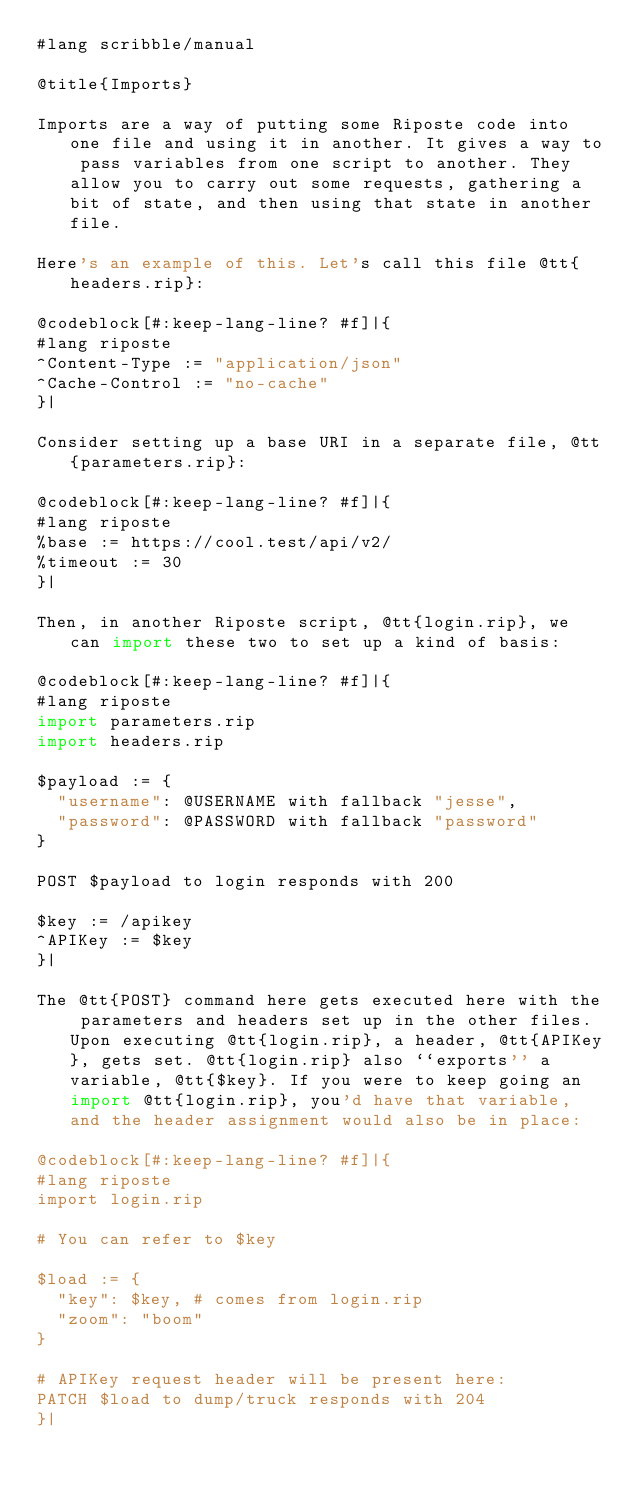Convert code to text. <code><loc_0><loc_0><loc_500><loc_500><_Racket_>#lang scribble/manual

@title{Imports}

Imports are a way of putting some Riposte code into one file and using it in another. It gives a way to pass variables from one script to another. They allow you to carry out some requests, gathering a bit of state, and then using that state in another file.

Here's an example of this. Let's call this file @tt{headers.rip}:

@codeblock[#:keep-lang-line? #f]|{
#lang riposte
^Content-Type := "application/json"
^Cache-Control := "no-cache"
}|

Consider setting up a base URI in a separate file, @tt{parameters.rip}:

@codeblock[#:keep-lang-line? #f]|{
#lang riposte
%base := https://cool.test/api/v2/
%timeout := 30
}|

Then, in another Riposte script, @tt{login.rip}, we can import these two to set up a kind of basis:

@codeblock[#:keep-lang-line? #f]|{
#lang riposte
import parameters.rip
import headers.rip

$payload := {
  "username": @USERNAME with fallback "jesse",
  "password": @PASSWORD with fallback "password"
}

POST $payload to login responds with 200

$key := /apikey
^APIKey := $key
}|

The @tt{POST} command here gets executed here with the parameters and headers set up in the other files. Upon executing @tt{login.rip}, a header, @tt{APIKey}, gets set. @tt{login.rip} also ``exports'' a variable, @tt{$key}. If you were to keep going an import @tt{login.rip}, you'd have that variable, and the header assignment would also be in place:

@codeblock[#:keep-lang-line? #f]|{
#lang riposte
import login.rip

# You can refer to $key

$load := {
  "key": $key, # comes from login.rip
  "zoom": "boom"
}

# APIKey request header will be present here:
PATCH $load to dump/truck responds with 204
}|
</code> 